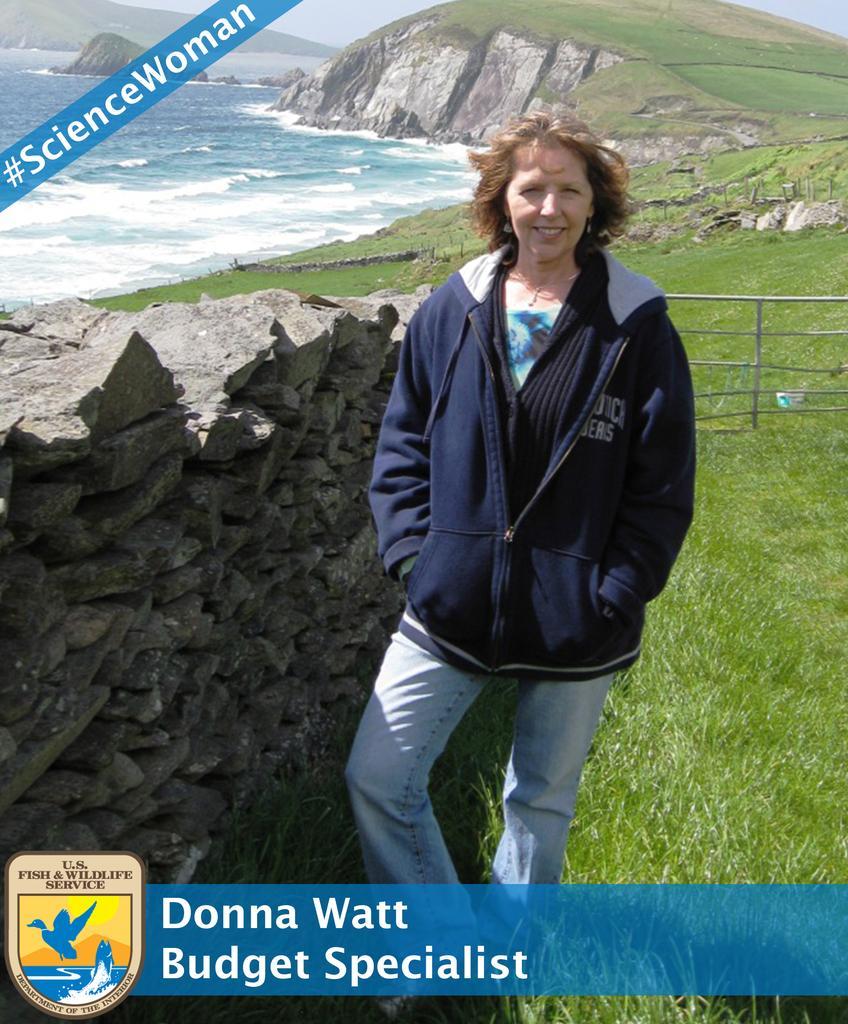Describe this image in one or two sentences. In this picture we can see a person in the jacket is standing on the grass. Behind the women there are rocks, iron grilles, water, hills and the sky. On the image there are watermarks and a logo. 